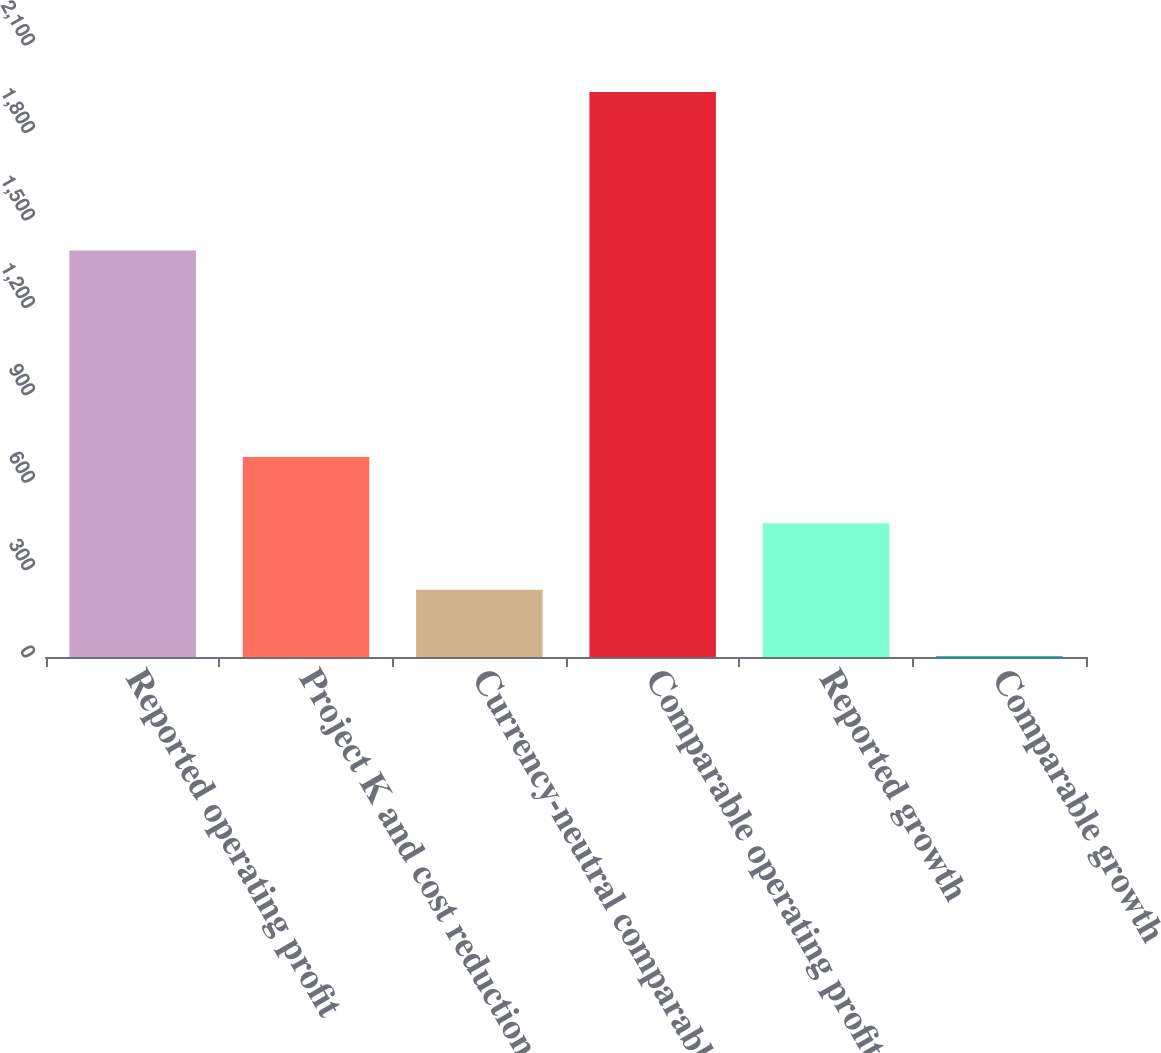Convert chart. <chart><loc_0><loc_0><loc_500><loc_500><bar_chart><fcel>Reported operating profit<fcel>Project K and cost reduction<fcel>Currency-neutral comparable<fcel>Comparable operating profit<fcel>Reported growth<fcel>Comparable growth<nl><fcel>1395<fcel>686.61<fcel>231.07<fcel>1939<fcel>458.84<fcel>3.3<nl></chart> 